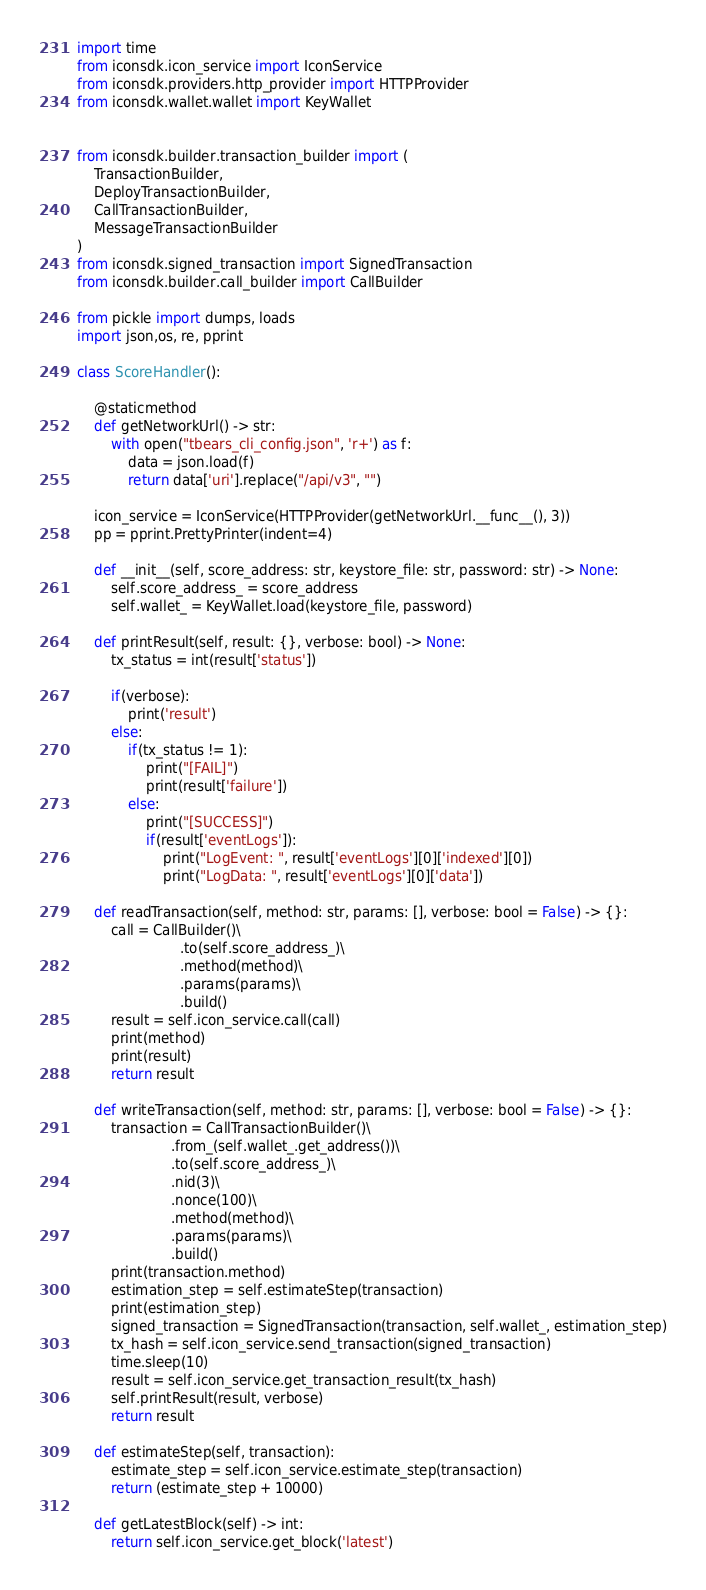Convert code to text. <code><loc_0><loc_0><loc_500><loc_500><_Python_>import time
from iconsdk.icon_service import IconService
from iconsdk.providers.http_provider import HTTPProvider
from iconsdk.wallet.wallet import KeyWallet


from iconsdk.builder.transaction_builder import (
    TransactionBuilder,
    DeployTransactionBuilder,
    CallTransactionBuilder,
    MessageTransactionBuilder
)
from iconsdk.signed_transaction import SignedTransaction
from iconsdk.builder.call_builder import CallBuilder

from pickle import dumps, loads
import json,os, re, pprint

class ScoreHandler():

    @staticmethod
    def getNetworkUrl() -> str:
        with open("tbears_cli_config.json", 'r+') as f:
            data = json.load(f)
            return data['uri'].replace("/api/v3", "")

    icon_service = IconService(HTTPProvider(getNetworkUrl.__func__(), 3))
    pp = pprint.PrettyPrinter(indent=4)

    def __init__(self, score_address: str, keystore_file: str, password: str) -> None:
        self.score_address_ = score_address
        self.wallet_ = KeyWallet.load(keystore_file, password)

    def printResult(self, result: {}, verbose: bool) -> None:
        tx_status = int(result['status'])

        if(verbose):
            print('result')
        else:
            if(tx_status != 1):
                print("[FAIL]")
                print(result['failure'])
            else:
                print("[SUCCESS]")
                if(result['eventLogs']):
                    print("LogEvent: ", result['eventLogs'][0]['indexed'][0])
                    print("LogData: ", result['eventLogs'][0]['data'])

    def readTransaction(self, method: str, params: [], verbose: bool = False) -> {}:
        call = CallBuilder()\
                        .to(self.score_address_)\
                        .method(method)\
                        .params(params)\
                        .build()
        result = self.icon_service.call(call)
        print(method)
        print(result)
        return result

    def writeTransaction(self, method: str, params: [], verbose: bool = False) -> {}:
        transaction = CallTransactionBuilder()\
                      .from_(self.wallet_.get_address())\
                      .to(self.score_address_)\
                      .nid(3)\
                      .nonce(100)\
                      .method(method)\
                      .params(params)\
                      .build()
        print(transaction.method)
        estimation_step = self.estimateStep(transaction)
        print(estimation_step)
        signed_transaction = SignedTransaction(transaction, self.wallet_, estimation_step)
        tx_hash = self.icon_service.send_transaction(signed_transaction)
        time.sleep(10)
        result = self.icon_service.get_transaction_result(tx_hash)
        self.printResult(result, verbose)
        return result

    def estimateStep(self, transaction):
        estimate_step = self.icon_service.estimate_step(transaction)
        return (estimate_step + 10000)

    def getLatestBlock(self) -> int:
        return self.icon_service.get_block('latest')
</code> 